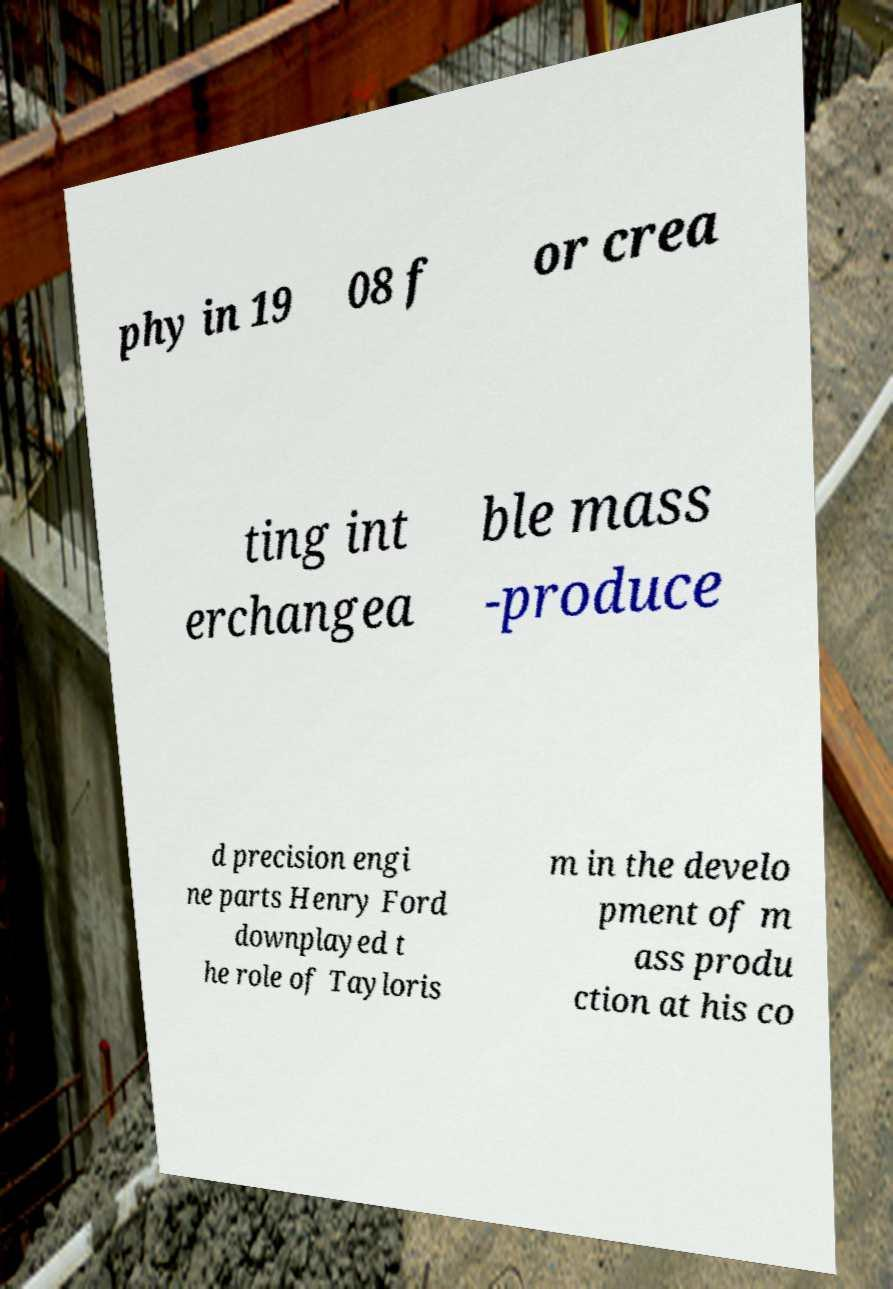What messages or text are displayed in this image? I need them in a readable, typed format. phy in 19 08 f or crea ting int erchangea ble mass -produce d precision engi ne parts Henry Ford downplayed t he role of Tayloris m in the develo pment of m ass produ ction at his co 